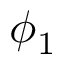Convert formula to latex. <formula><loc_0><loc_0><loc_500><loc_500>\phi _ { 1 }</formula> 